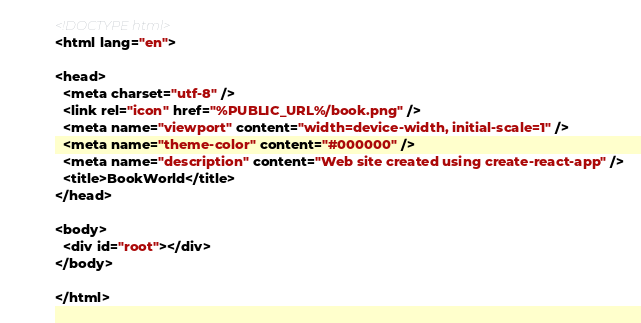Convert code to text. <code><loc_0><loc_0><loc_500><loc_500><_HTML_><!DOCTYPE html>
<html lang="en">

<head>
  <meta charset="utf-8" />
  <link rel="icon" href="%PUBLIC_URL%/book.png" />
  <meta name="viewport" content="width=device-width, initial-scale=1" />
  <meta name="theme-color" content="#000000" />
  <meta name="description" content="Web site created using create-react-app" />
  <title>BookWorld</title>
</head>

<body>
  <div id="root"></div>
</body>

</html></code> 